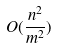Convert formula to latex. <formula><loc_0><loc_0><loc_500><loc_500>O ( \frac { n ^ { 2 } } { m ^ { 2 } } )</formula> 